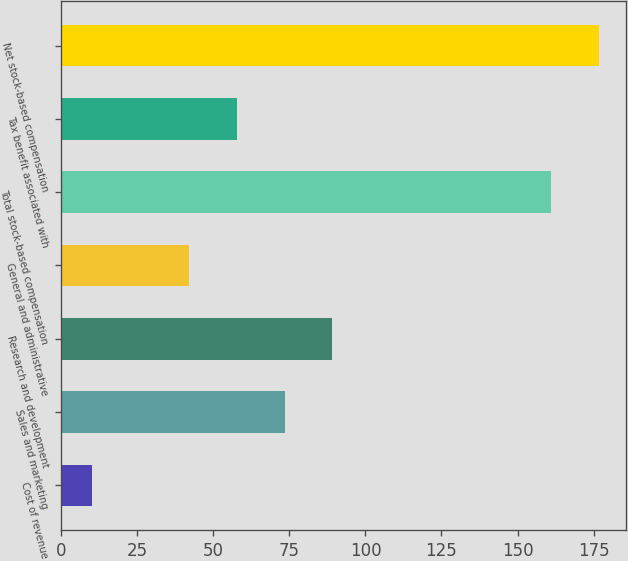<chart> <loc_0><loc_0><loc_500><loc_500><bar_chart><fcel>Cost of revenue<fcel>Sales and marketing<fcel>Research and development<fcel>General and administrative<fcel>Total stock-based compensation<fcel>Tax benefit associated with<fcel>Net stock-based compensation<nl><fcel>10<fcel>73.4<fcel>89.1<fcel>42<fcel>161<fcel>57.7<fcel>176.7<nl></chart> 